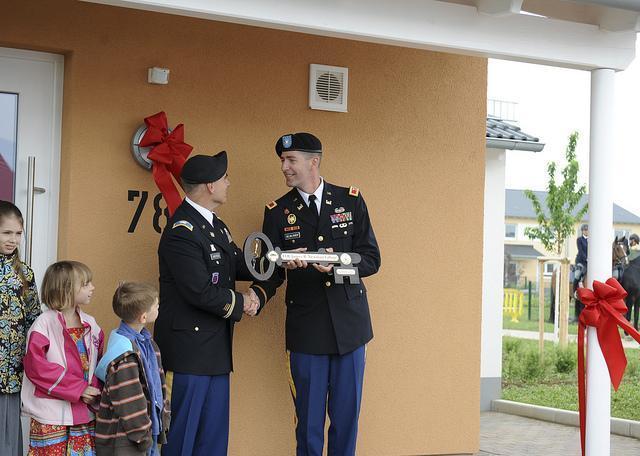How many kids are there?
Give a very brief answer. 3. How many people are in the picture?
Give a very brief answer. 5. How many ears does the giraffe have?
Give a very brief answer. 0. 